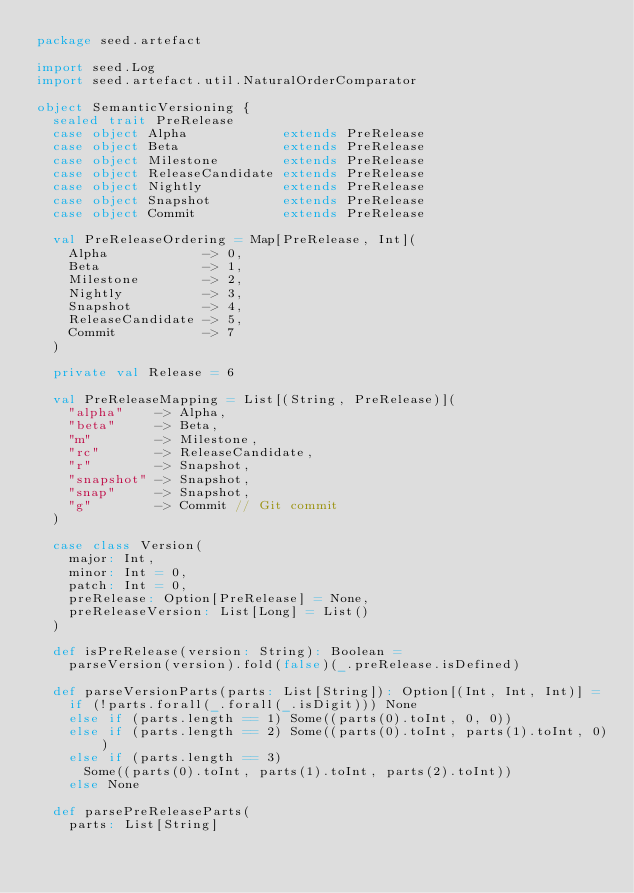<code> <loc_0><loc_0><loc_500><loc_500><_Scala_>package seed.artefact

import seed.Log
import seed.artefact.util.NaturalOrderComparator

object SemanticVersioning {
  sealed trait PreRelease
  case object Alpha            extends PreRelease
  case object Beta             extends PreRelease
  case object Milestone        extends PreRelease
  case object ReleaseCandidate extends PreRelease
  case object Nightly          extends PreRelease
  case object Snapshot         extends PreRelease
  case object Commit           extends PreRelease

  val PreReleaseOrdering = Map[PreRelease, Int](
    Alpha            -> 0,
    Beta             -> 1,
    Milestone        -> 2,
    Nightly          -> 3,
    Snapshot         -> 4,
    ReleaseCandidate -> 5,
    Commit           -> 7
  )

  private val Release = 6

  val PreReleaseMapping = List[(String, PreRelease)](
    "alpha"    -> Alpha,
    "beta"     -> Beta,
    "m"        -> Milestone,
    "rc"       -> ReleaseCandidate,
    "r"        -> Snapshot,
    "snapshot" -> Snapshot,
    "snap"     -> Snapshot,
    "g"        -> Commit // Git commit
  )

  case class Version(
    major: Int,
    minor: Int = 0,
    patch: Int = 0,
    preRelease: Option[PreRelease] = None,
    preReleaseVersion: List[Long] = List()
  )

  def isPreRelease(version: String): Boolean =
    parseVersion(version).fold(false)(_.preRelease.isDefined)

  def parseVersionParts(parts: List[String]): Option[(Int, Int, Int)] =
    if (!parts.forall(_.forall(_.isDigit))) None
    else if (parts.length == 1) Some((parts(0).toInt, 0, 0))
    else if (parts.length == 2) Some((parts(0).toInt, parts(1).toInt, 0))
    else if (parts.length == 3)
      Some((parts(0).toInt, parts(1).toInt, parts(2).toInt))
    else None

  def parsePreReleaseParts(
    parts: List[String]</code> 